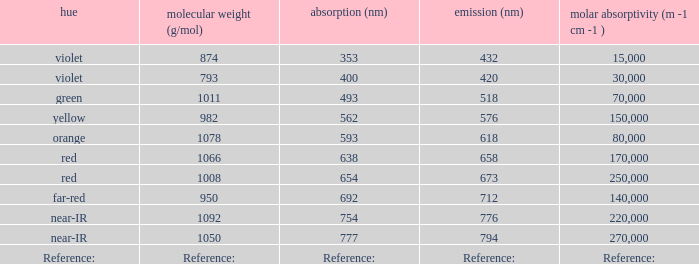Which Emission (in nanometers) that has a molar mass of 1078 g/mol? 618.0. 